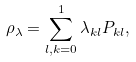<formula> <loc_0><loc_0><loc_500><loc_500>\rho _ { \lambda } = \sum _ { l , k = 0 } ^ { 1 } \lambda _ { k l } P _ { k l } ,</formula> 